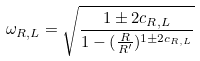Convert formula to latex. <formula><loc_0><loc_0><loc_500><loc_500>\omega _ { R , L } = \sqrt { \frac { 1 \pm 2 c _ { R , L } } { 1 - ( \frac { R } { R ^ { \prime } } ) ^ { 1 \pm 2 c _ { R , L } } } }</formula> 